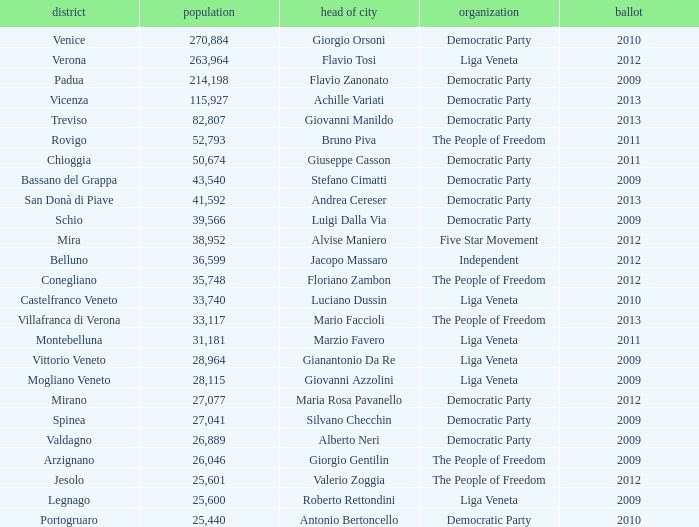Parse the full table. {'header': ['district', 'population', 'head of city', 'organization', 'ballot'], 'rows': [['Venice', '270,884', 'Giorgio Orsoni', 'Democratic Party', '2010'], ['Verona', '263,964', 'Flavio Tosi', 'Liga Veneta', '2012'], ['Padua', '214,198', 'Flavio Zanonato', 'Democratic Party', '2009'], ['Vicenza', '115,927', 'Achille Variati', 'Democratic Party', '2013'], ['Treviso', '82,807', 'Giovanni Manildo', 'Democratic Party', '2013'], ['Rovigo', '52,793', 'Bruno Piva', 'The People of Freedom', '2011'], ['Chioggia', '50,674', 'Giuseppe Casson', 'Democratic Party', '2011'], ['Bassano del Grappa', '43,540', 'Stefano Cimatti', 'Democratic Party', '2009'], ['San Donà di Piave', '41,592', 'Andrea Cereser', 'Democratic Party', '2013'], ['Schio', '39,566', 'Luigi Dalla Via', 'Democratic Party', '2009'], ['Mira', '38,952', 'Alvise Maniero', 'Five Star Movement', '2012'], ['Belluno', '36,599', 'Jacopo Massaro', 'Independent', '2012'], ['Conegliano', '35,748', 'Floriano Zambon', 'The People of Freedom', '2012'], ['Castelfranco Veneto', '33,740', 'Luciano Dussin', 'Liga Veneta', '2010'], ['Villafranca di Verona', '33,117', 'Mario Faccioli', 'The People of Freedom', '2013'], ['Montebelluna', '31,181', 'Marzio Favero', 'Liga Veneta', '2011'], ['Vittorio Veneto', '28,964', 'Gianantonio Da Re', 'Liga Veneta', '2009'], ['Mogliano Veneto', '28,115', 'Giovanni Azzolini', 'Liga Veneta', '2009'], ['Mirano', '27,077', 'Maria Rosa Pavanello', 'Democratic Party', '2012'], ['Spinea', '27,041', 'Silvano Checchin', 'Democratic Party', '2009'], ['Valdagno', '26,889', 'Alberto Neri', 'Democratic Party', '2009'], ['Arzignano', '26,046', 'Giorgio Gentilin', 'The People of Freedom', '2009'], ['Jesolo', '25,601', 'Valerio Zoggia', 'The People of Freedom', '2012'], ['Legnago', '25,600', 'Roberto Rettondini', 'Liga Veneta', '2009'], ['Portogruaro', '25,440', 'Antonio Bertoncello', 'Democratic Party', '2010']]} In the election earlier than 2012 how many Inhabitants had a Party of five star movement? None. 